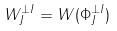Convert formula to latex. <formula><loc_0><loc_0><loc_500><loc_500>W _ { J } ^ { \perp I } = W ( \Phi _ { J } ^ { \perp I } )</formula> 